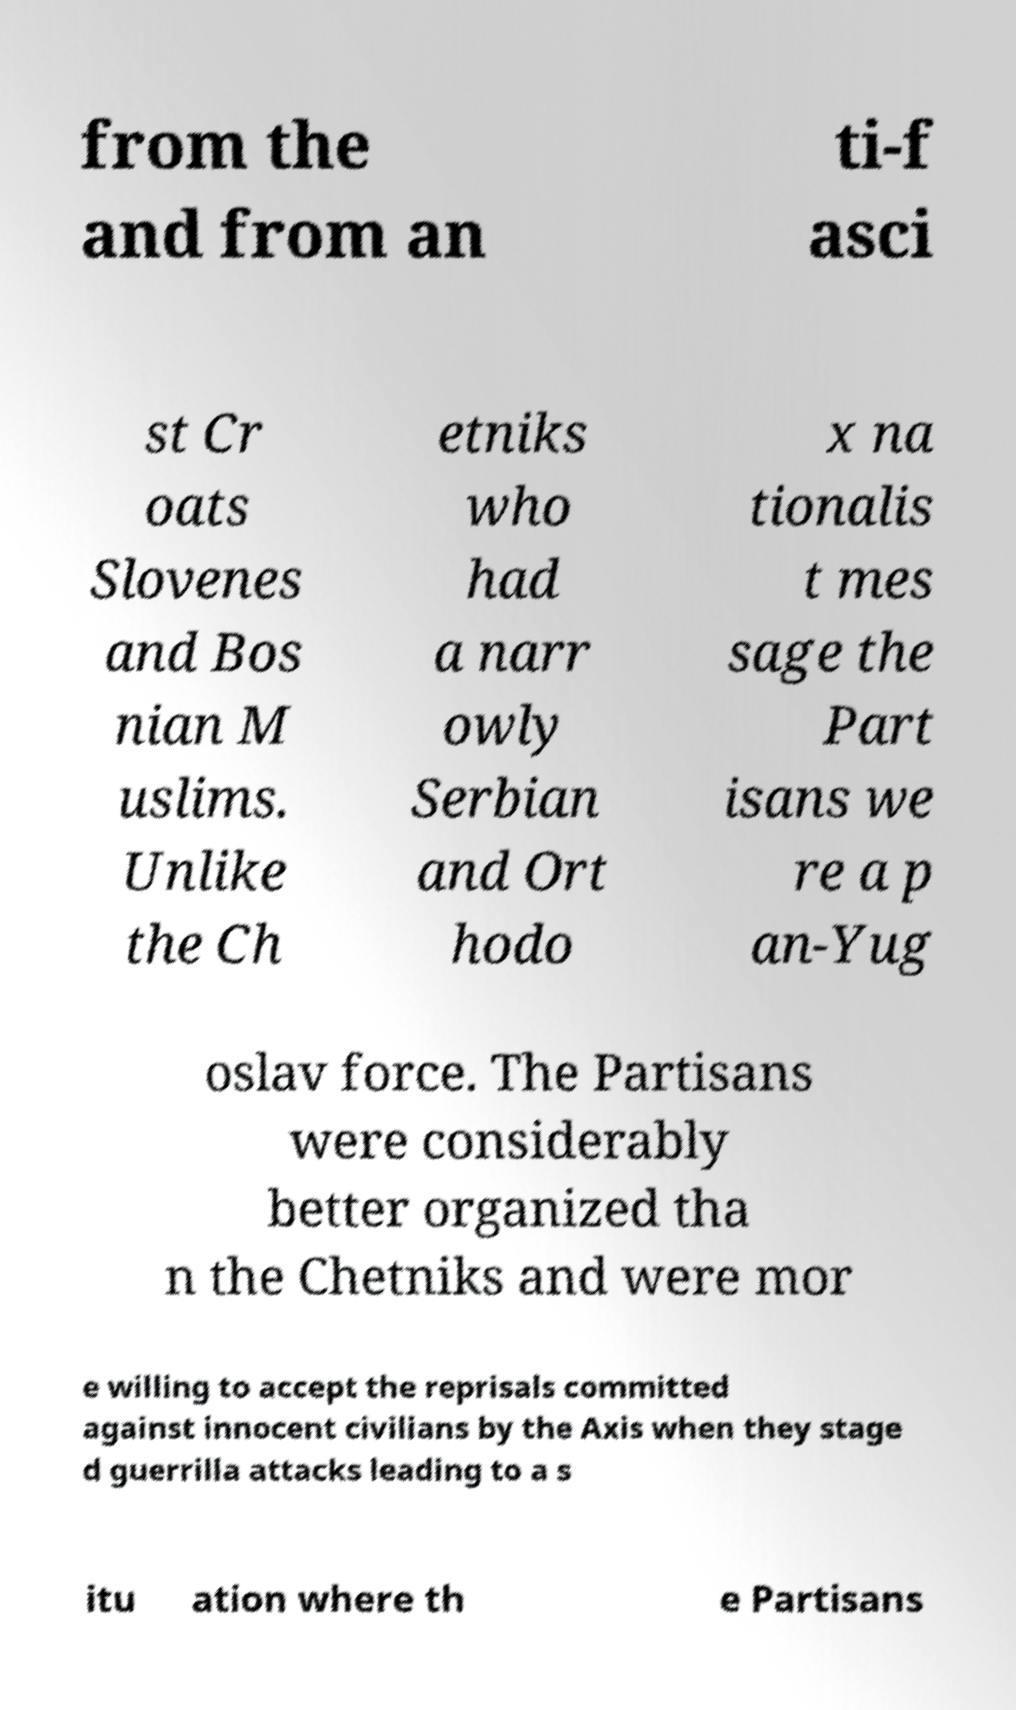Could you extract and type out the text from this image? from the and from an ti-f asci st Cr oats Slovenes and Bos nian M uslims. Unlike the Ch etniks who had a narr owly Serbian and Ort hodo x na tionalis t mes sage the Part isans we re a p an-Yug oslav force. The Partisans were considerably better organized tha n the Chetniks and were mor e willing to accept the reprisals committed against innocent civilians by the Axis when they stage d guerrilla attacks leading to a s itu ation where th e Partisans 